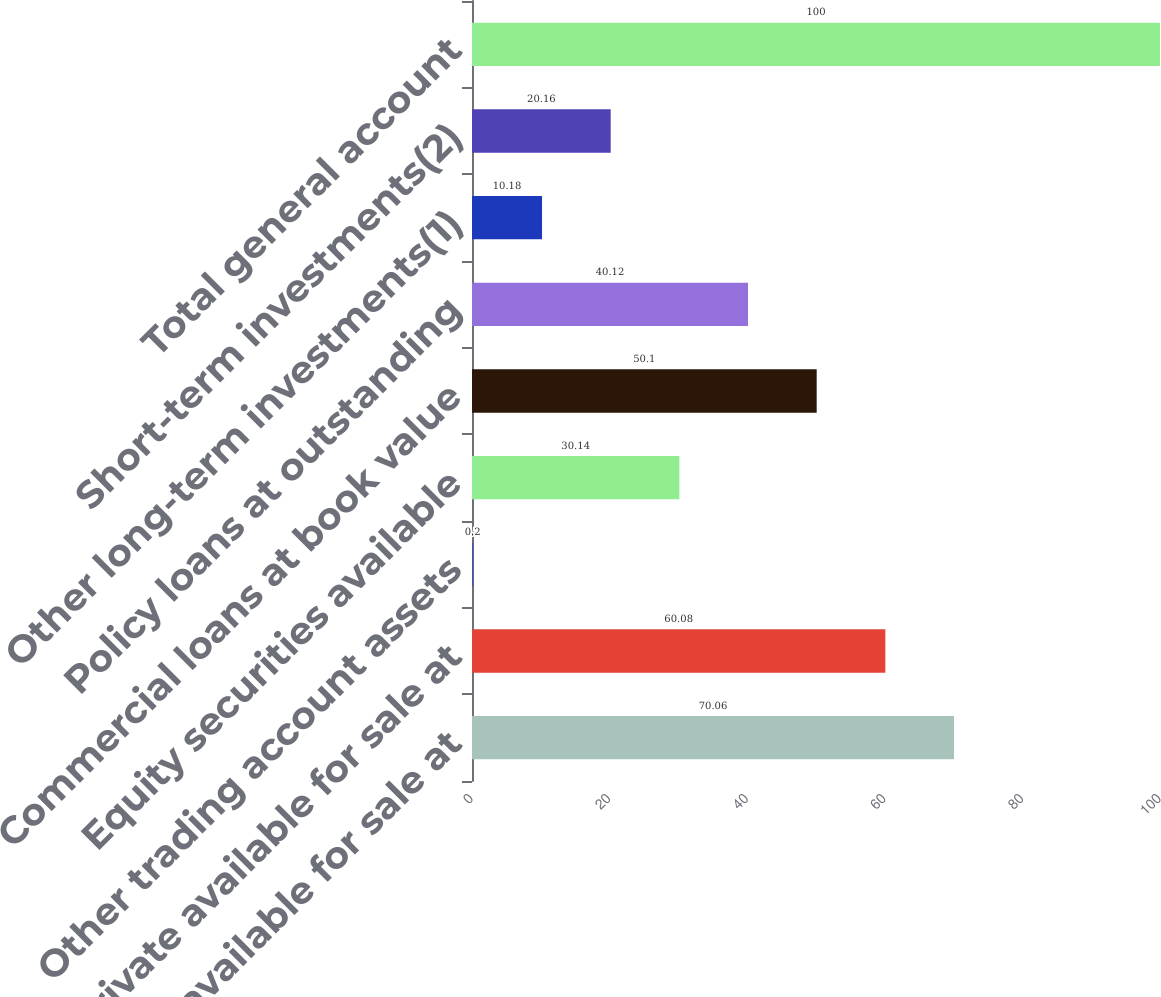Convert chart. <chart><loc_0><loc_0><loc_500><loc_500><bar_chart><fcel>Public available for sale at<fcel>Private available for sale at<fcel>Other trading account assets<fcel>Equity securities available<fcel>Commercial loans at book value<fcel>Policy loans at outstanding<fcel>Other long-term investments(1)<fcel>Short-term investments(2)<fcel>Total general account<nl><fcel>70.06<fcel>60.08<fcel>0.2<fcel>30.14<fcel>50.1<fcel>40.12<fcel>10.18<fcel>20.16<fcel>100<nl></chart> 